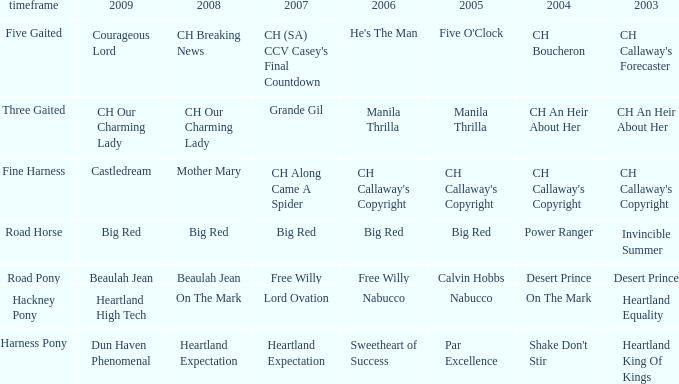What year is the 2007 big red? Road Horse. 